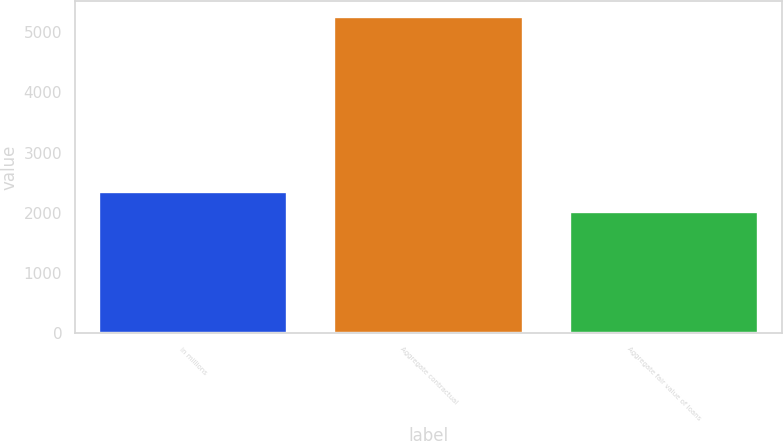Convert chart. <chart><loc_0><loc_0><loc_500><loc_500><bar_chart><fcel>in millions<fcel>Aggregate contractual<fcel>Aggregate fair value of loans<nl><fcel>2335<fcel>5260<fcel>2010<nl></chart> 